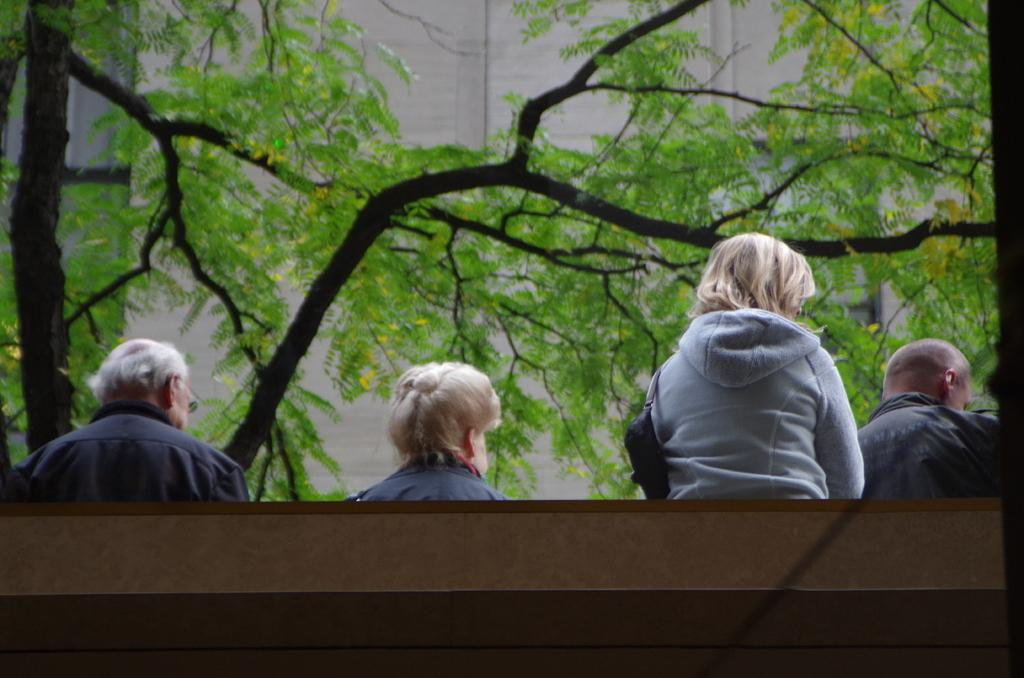How many people are in the image? There are a few people in the image. What is located in front of the people? There are trees and a building in front of the people. What type of corn can be seen being destroyed by a marble in the image? There is no corn, destruction, or marble present in the image. 